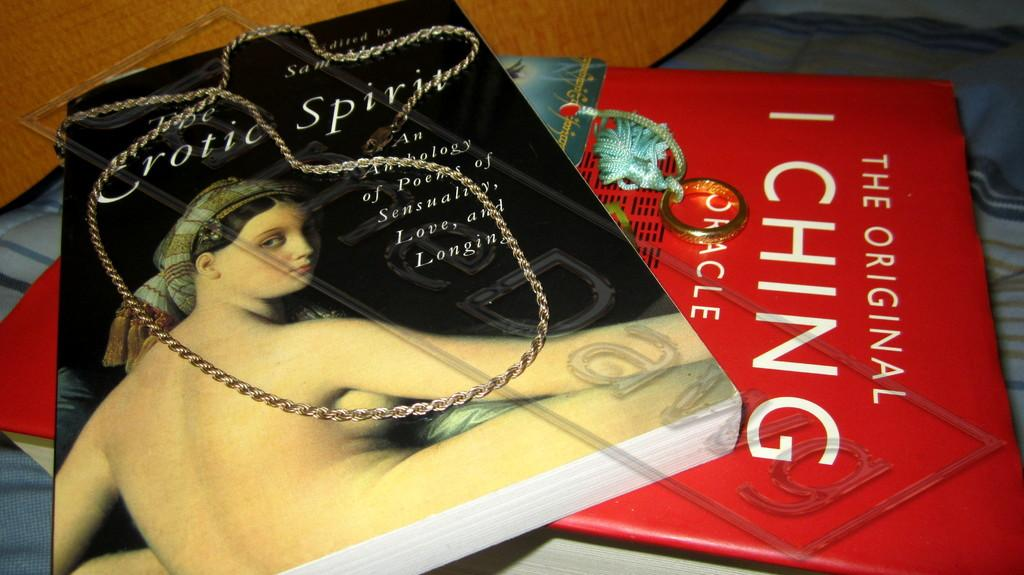Provide a one-sentence caption for the provided image. A red book titled "The Original I Ching" sits under another book. 